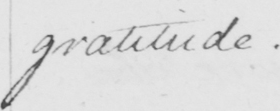What is written in this line of handwriting? gratitude .  _ 